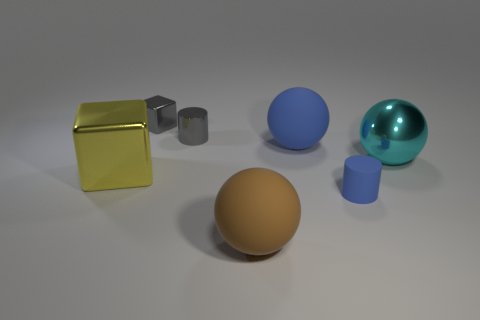Subtract all brown matte spheres. How many spheres are left? 2 Add 2 small blue rubber cylinders. How many objects exist? 9 Subtract all cylinders. How many objects are left? 5 Subtract all yellow balls. Subtract all purple cylinders. How many balls are left? 3 Subtract 0 yellow balls. How many objects are left? 7 Subtract all yellow metallic objects. Subtract all blue cylinders. How many objects are left? 5 Add 4 large matte spheres. How many large matte spheres are left? 6 Add 6 cyan matte things. How many cyan matte things exist? 6 